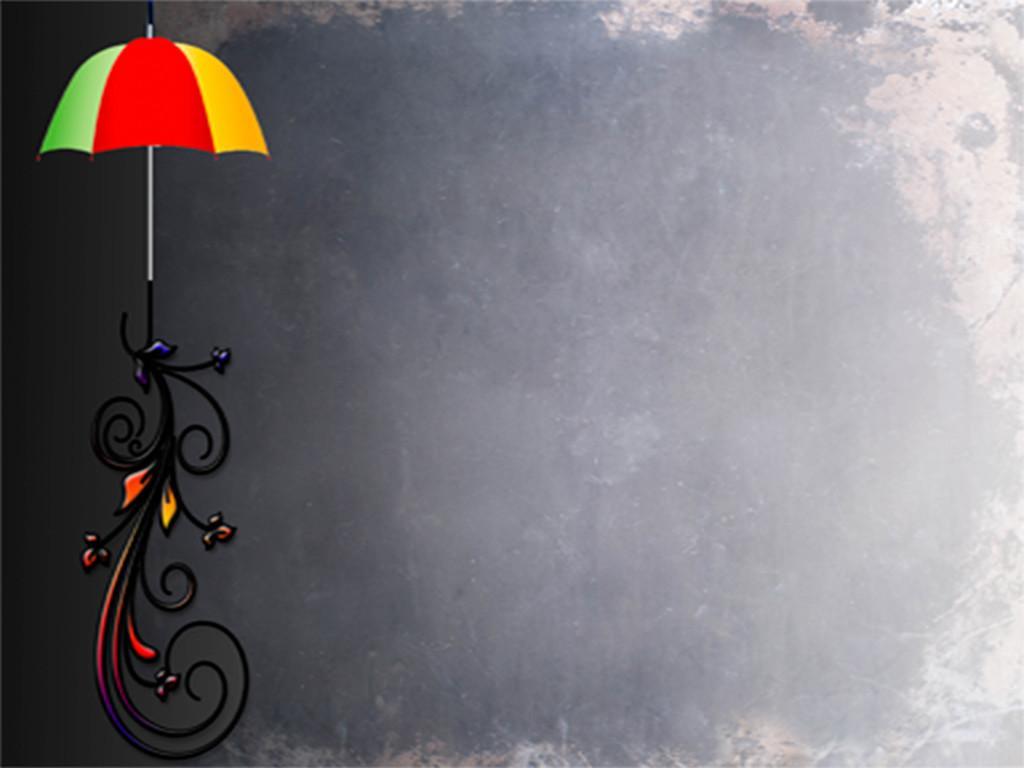In one or two sentences, can you explain what this image depicts? In this image, we can see an umbrella on the design which is on the black background. 